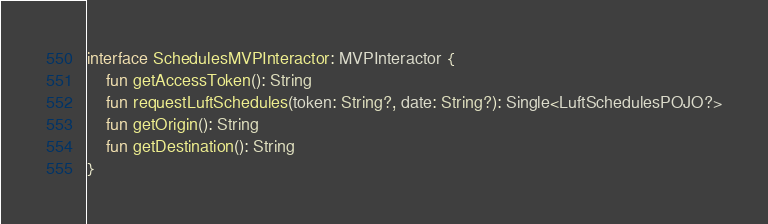<code> <loc_0><loc_0><loc_500><loc_500><_Kotlin_>interface SchedulesMVPInteractor: MVPInteractor {
    fun getAccessToken(): String
    fun requestLuftSchedules(token: String?, date: String?): Single<LuftSchedulesPOJO?>
    fun getOrigin(): String
    fun getDestination(): String
}
</code> 